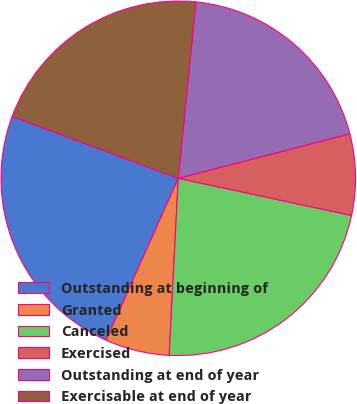Convert chart. <chart><loc_0><loc_0><loc_500><loc_500><pie_chart><fcel>Outstanding at beginning of<fcel>Granted<fcel>Canceled<fcel>Exercised<fcel>Outstanding at end of year<fcel>Exercisable at end of year<nl><fcel>24.0%<fcel>5.86%<fcel>22.46%<fcel>7.4%<fcel>19.37%<fcel>20.91%<nl></chart> 